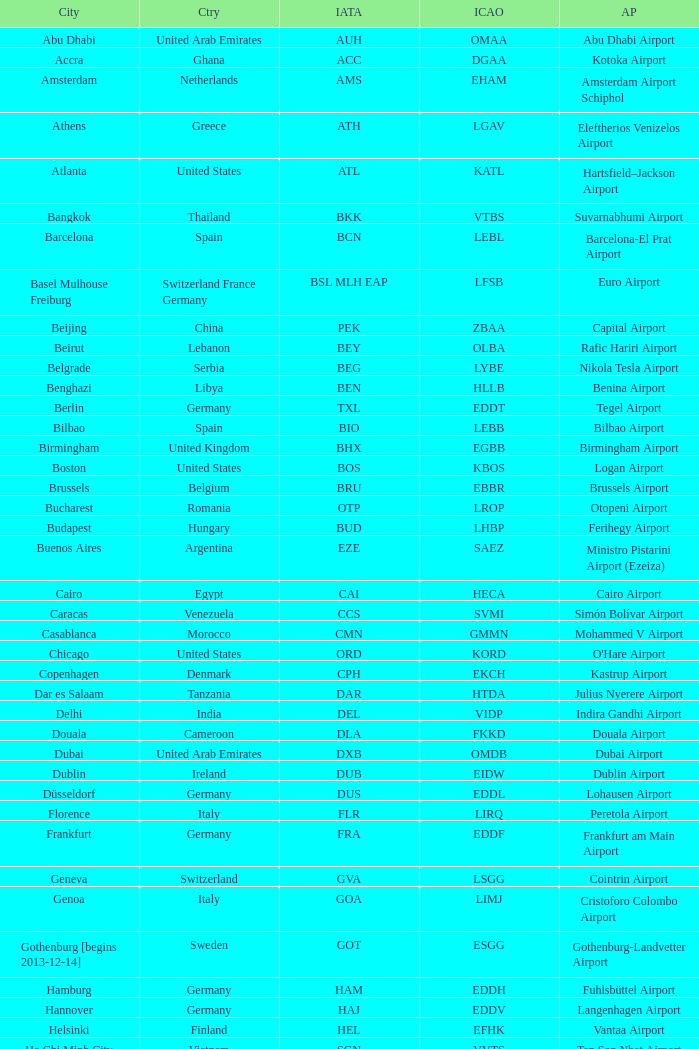What is the ICAO of Douala city? FKKD. 